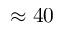<formula> <loc_0><loc_0><loc_500><loc_500>\approx 4 0</formula> 